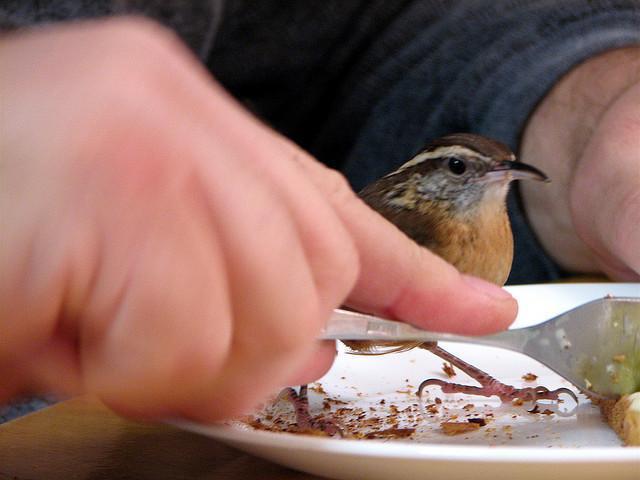How many forks are there?
Give a very brief answer. 1. How many zebras are standing in this image ?
Give a very brief answer. 0. 